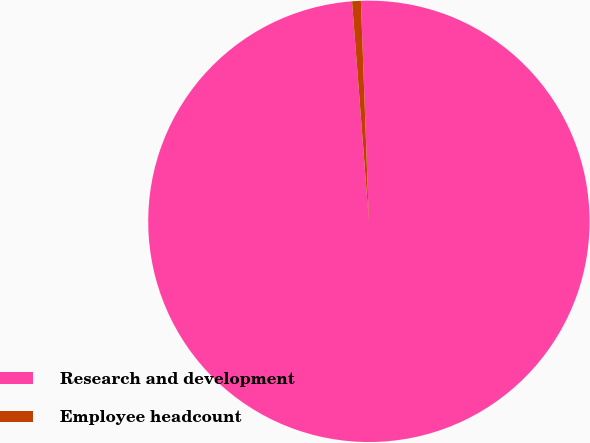<chart> <loc_0><loc_0><loc_500><loc_500><pie_chart><fcel>Research and development<fcel>Employee headcount<nl><fcel>99.36%<fcel>0.64%<nl></chart> 